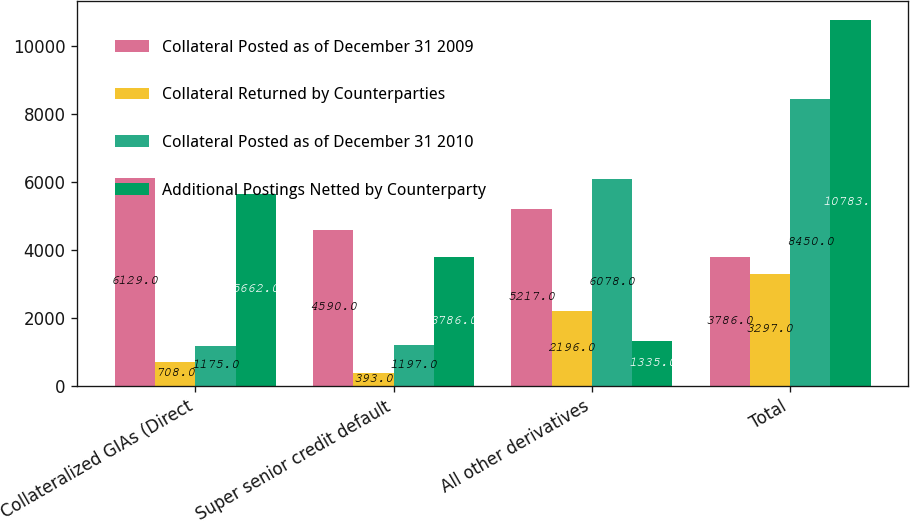<chart> <loc_0><loc_0><loc_500><loc_500><stacked_bar_chart><ecel><fcel>Collateralized GIAs (Direct<fcel>Super senior credit default<fcel>All other derivatives<fcel>Total<nl><fcel>Collateral Posted as of December 31 2009<fcel>6129<fcel>4590<fcel>5217<fcel>3786<nl><fcel>Collateral Returned by Counterparties<fcel>708<fcel>393<fcel>2196<fcel>3297<nl><fcel>Collateral Posted as of December 31 2010<fcel>1175<fcel>1197<fcel>6078<fcel>8450<nl><fcel>Additional Postings Netted by Counterparty<fcel>5662<fcel>3786<fcel>1335<fcel>10783<nl></chart> 